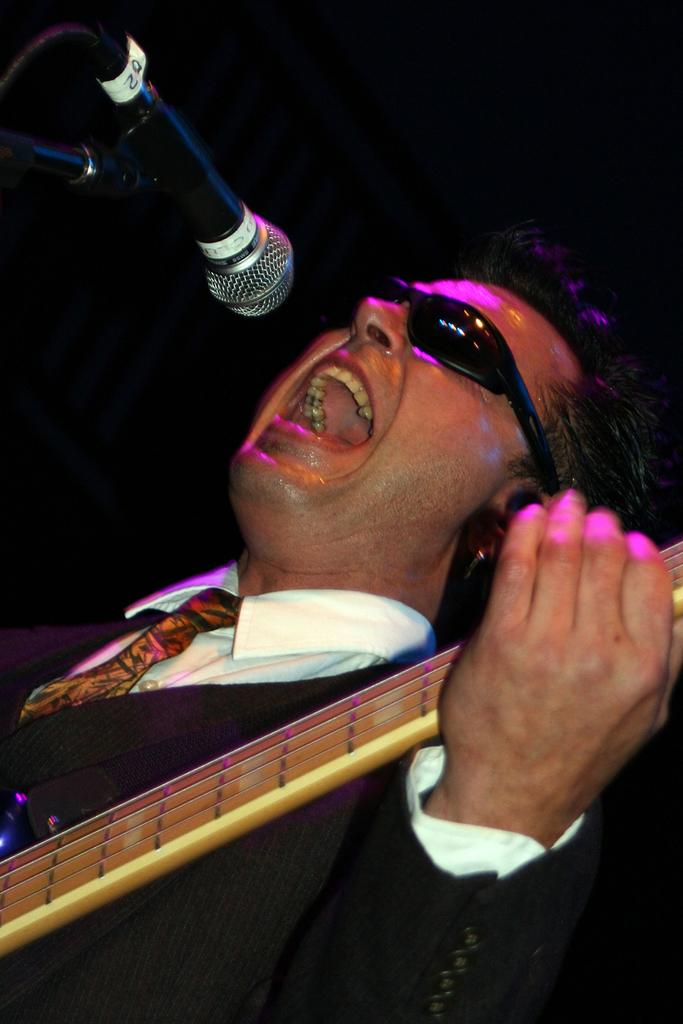What is the main subject of the image? There is a person in the image. What is the person wearing on their upper body? The person is wearing a white shirt and a black blazer. What object is the person holding in their hand? The person is holding a guitar in their hand. What accessory is the person wearing on their face? The person is wearing black sunglasses. What is in front of the person? There is a microphone in front of the person. What is the person's mom doing in the image? There is no mention of the person's mom in the image or the provided facts. 